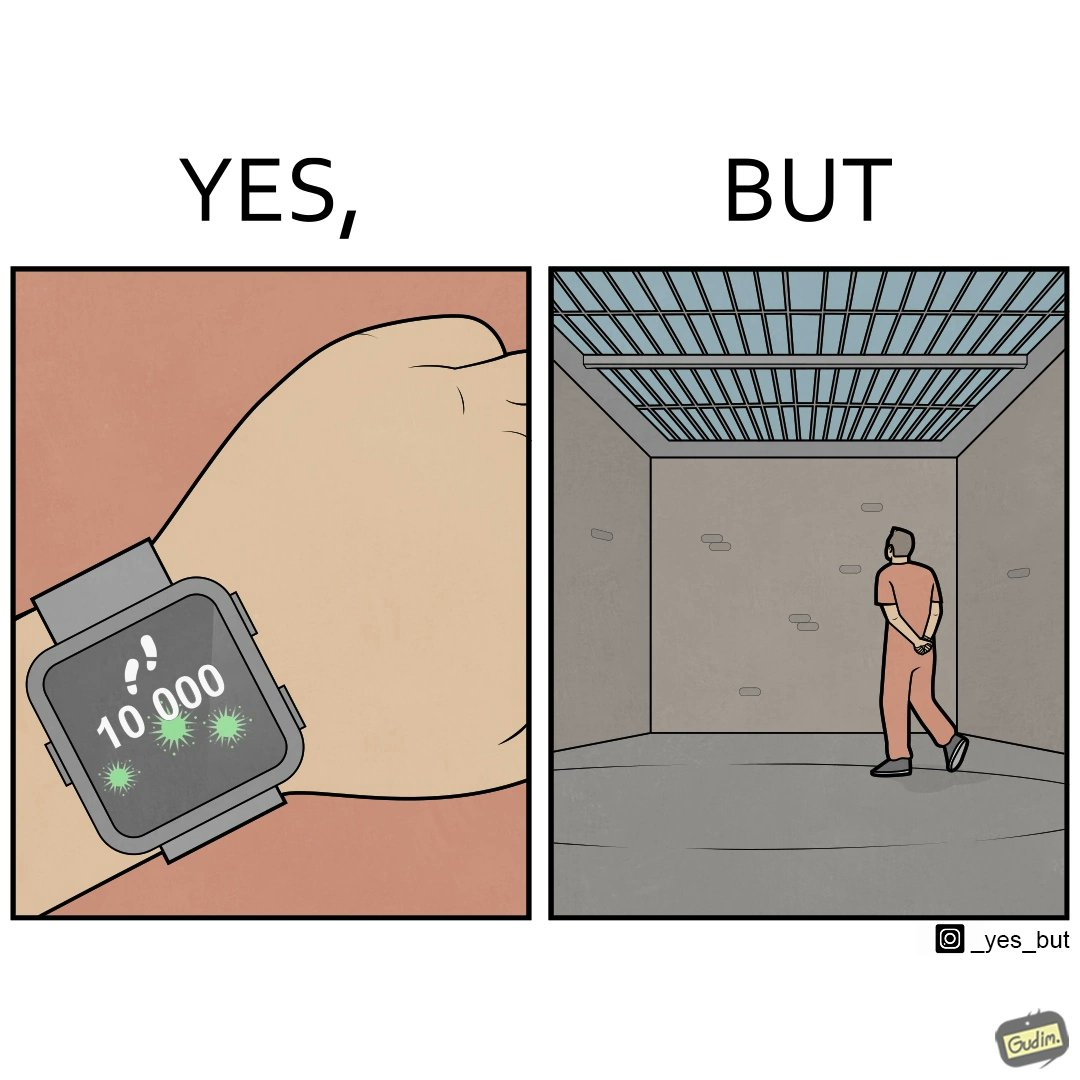What do you see in each half of this image? In the left part of the image: a smartwatch on a person's wrist showing 10,000 steps completed, indicating that a goal has been reached. In the right part of the image: a person walking in orange clothes, who is apparently a prisoner inside a jail. 